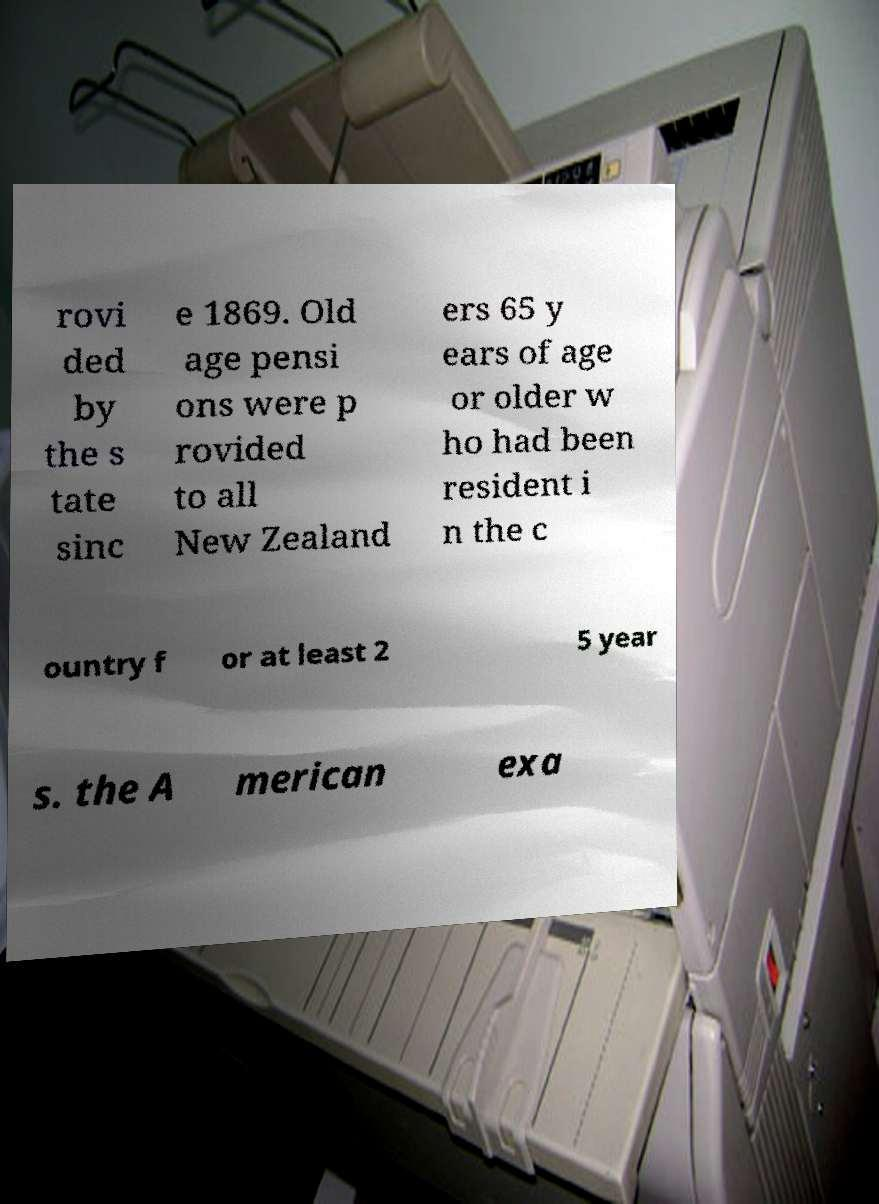There's text embedded in this image that I need extracted. Can you transcribe it verbatim? rovi ded by the s tate sinc e 1869. Old age pensi ons were p rovided to all New Zealand ers 65 y ears of age or older w ho had been resident i n the c ountry f or at least 2 5 year s. the A merican exa 